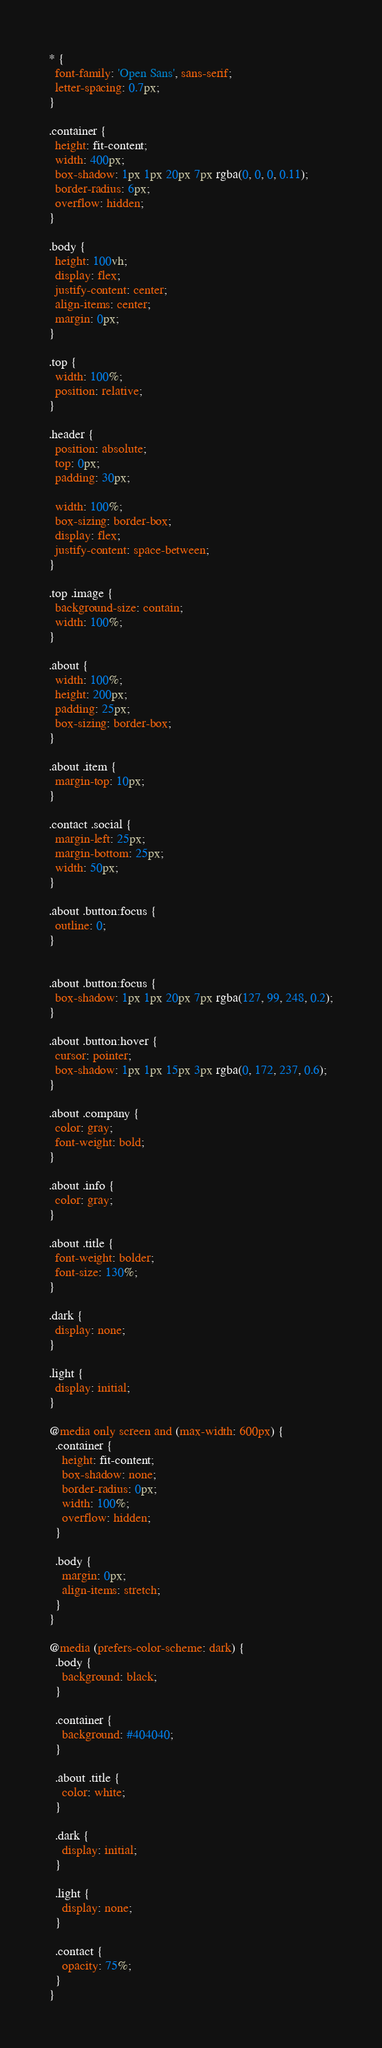Convert code to text. <code><loc_0><loc_0><loc_500><loc_500><_CSS_>* {
  font-family: 'Open Sans', sans-serif;
  letter-spacing: 0.7px;
}

.container {
  height: fit-content;
  width: 400px;
  box-shadow: 1px 1px 20px 7px rgba(0, 0, 0, 0.11);
  border-radius: 6px;
  overflow: hidden;
}

.body {
  height: 100vh;
  display: flex;
  justify-content: center;
  align-items: center;
  margin: 0px;
}

.top {
  width: 100%;
  position: relative;
}

.header {
  position: absolute;
  top: 0px;
  padding: 30px;

  width: 100%;
  box-sizing: border-box;
  display: flex;
  justify-content: space-between;
}

.top .image {
  background-size: contain;
  width: 100%;
}

.about {
  width: 100%;
  height: 200px;
  padding: 25px;
  box-sizing: border-box;
}

.about .item {
  margin-top: 10px;
}

.contact .social {
  margin-left: 25px;
  margin-bottom: 25px;
  width: 50px;
}

.about .button:focus {
  outline: 0;
}


.about .button:focus {
  box-shadow: 1px 1px 20px 7px rgba(127, 99, 248, 0.2);
}

.about .button:hover {
  cursor: pointer;
  box-shadow: 1px 1px 15px 3px rgba(0, 172, 237, 0.6);
}

.about .company {
  color: gray;
  font-weight: bold;
}

.about .info {
  color: gray;
}

.about .title {
  font-weight: bolder;
  font-size: 130%;
}

.dark {
  display: none;
}

.light {
  display: initial;
}

@media only screen and (max-width: 600px) {
  .container {
    height: fit-content;
    box-shadow: none;
    border-radius: 0px;
    width: 100%;
    overflow: hidden;
  }

  .body {
    margin: 0px;
    align-items: stretch;
  }
}

@media (prefers-color-scheme: dark) {
  .body {
    background: black;
  }

  .container {
    background: #404040;
  }

  .about .title {
    color: white;
  }

  .dark {
    display: initial;
  }

  .light {
    display: none;
  }

  .contact {
    opacity: 75%;
  }
}
</code> 